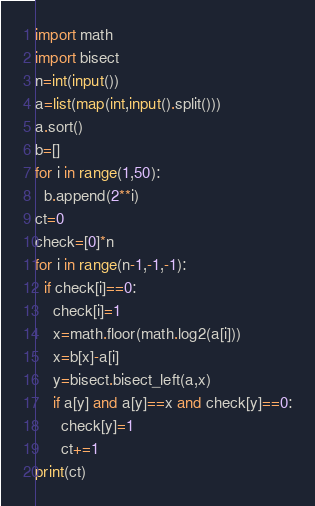Convert code to text. <code><loc_0><loc_0><loc_500><loc_500><_Python_>import math
import bisect
n=int(input())
a=list(map(int,input().split()))
a.sort()
b=[]
for i in range(1,50):
  b.append(2**i)
ct=0
check=[0]*n
for i in range(n-1,-1,-1):
  if check[i]==0:
    check[i]=1
    x=math.floor(math.log2(a[i]))
    x=b[x]-a[i]
    y=bisect.bisect_left(a,x)
    if a[y] and a[y]==x and check[y]==0:
      check[y]=1
      ct+=1
print(ct)</code> 